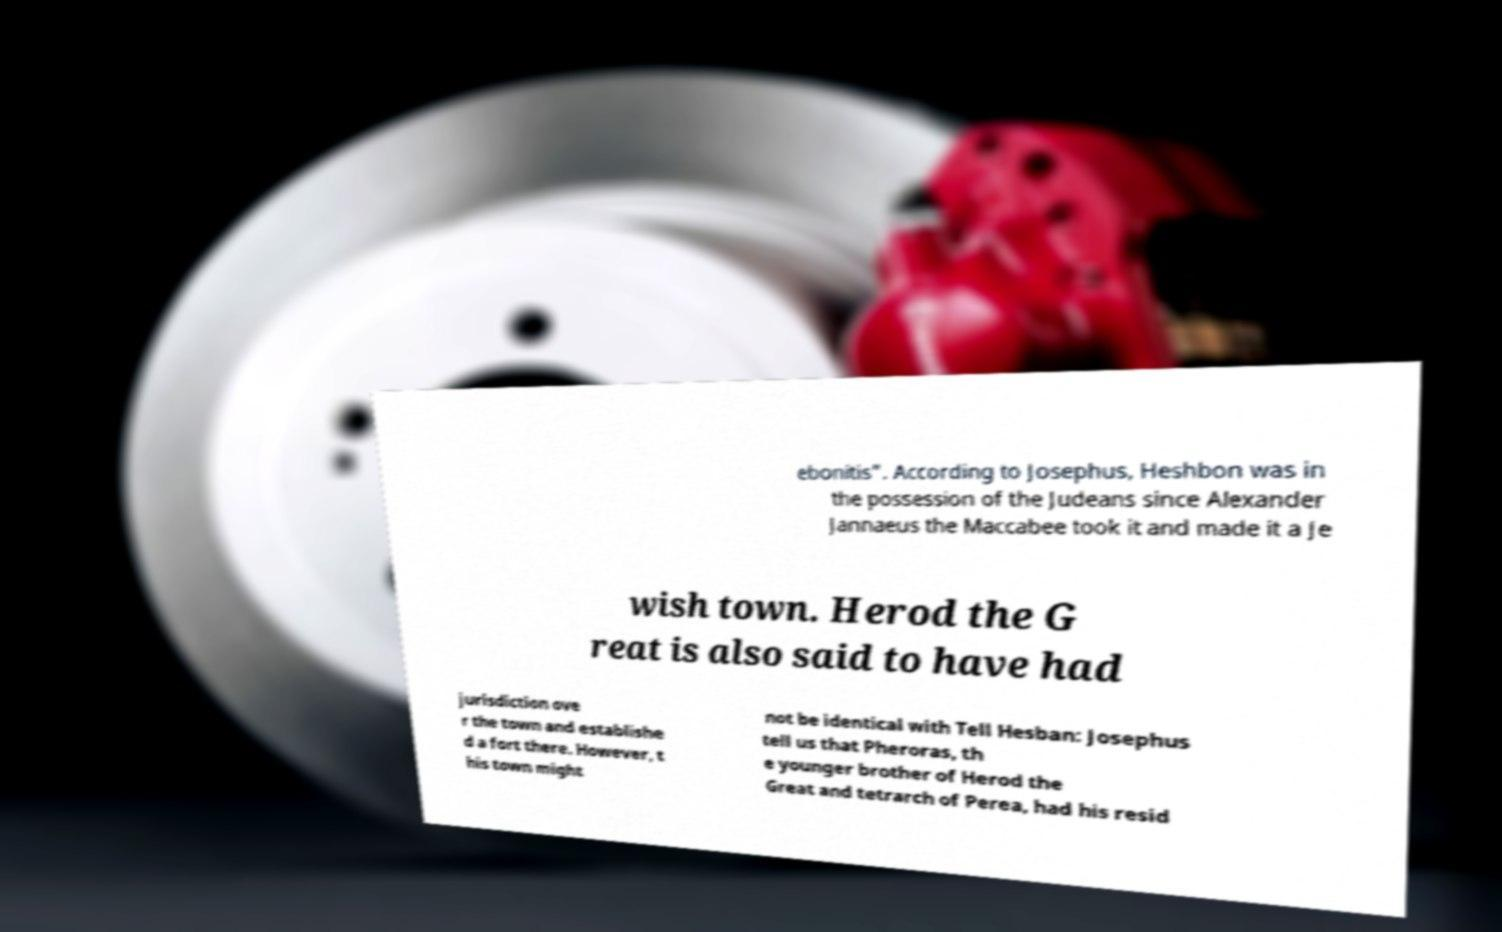Can you read and provide the text displayed in the image?This photo seems to have some interesting text. Can you extract and type it out for me? ebonitis". According to Josephus, Heshbon was in the possession of the Judeans since Alexander Jannaeus the Maccabee took it and made it a Je wish town. Herod the G reat is also said to have had jurisdiction ove r the town and establishe d a fort there. However, t his town might not be identical with Tell Hesban: Josephus tell us that Pheroras, th e younger brother of Herod the Great and tetrarch of Perea, had his resid 